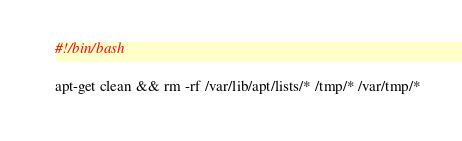<code> <loc_0><loc_0><loc_500><loc_500><_Bash_>#!/bin/bash

apt-get clean && rm -rf /var/lib/apt/lists/* /tmp/* /var/tmp/*
</code> 